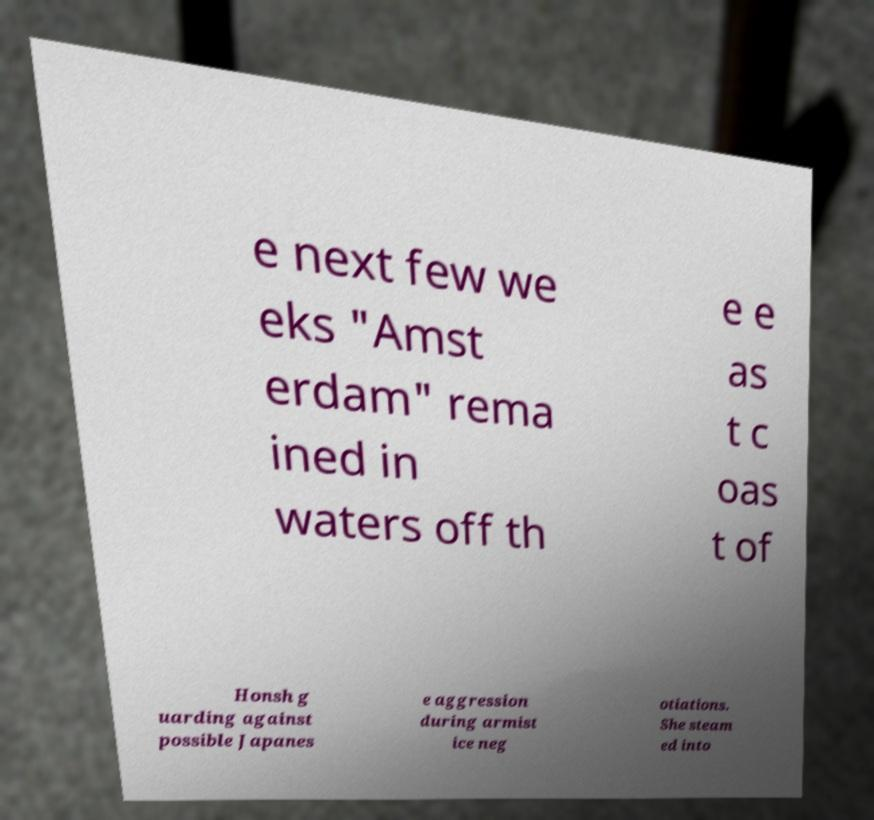Please read and relay the text visible in this image. What does it say? e next few we eks "Amst erdam" rema ined in waters off th e e as t c oas t of Honsh g uarding against possible Japanes e aggression during armist ice neg otiations. She steam ed into 